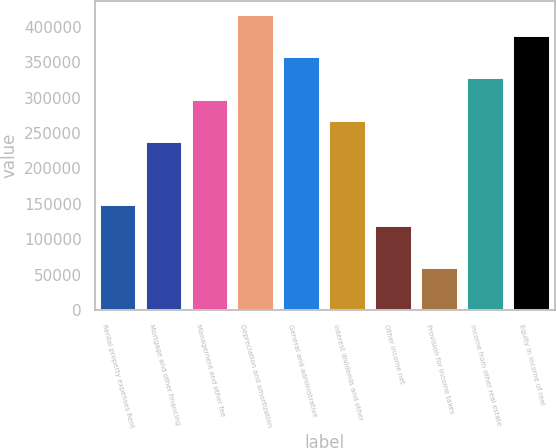Convert chart to OTSL. <chart><loc_0><loc_0><loc_500><loc_500><bar_chart><fcel>Rental property expenses Rent<fcel>Mortgage and other financing<fcel>Management and other fee<fcel>Depreciation and amortization<fcel>General and administrative<fcel>Interest dividends and other<fcel>Other income net<fcel>Provision for income taxes<fcel>Income from other real estate<fcel>Equity in income of real<nl><fcel>148569<fcel>237710<fcel>297137<fcel>415991<fcel>356564<fcel>267423<fcel>118856<fcel>59428.4<fcel>326851<fcel>386278<nl></chart> 